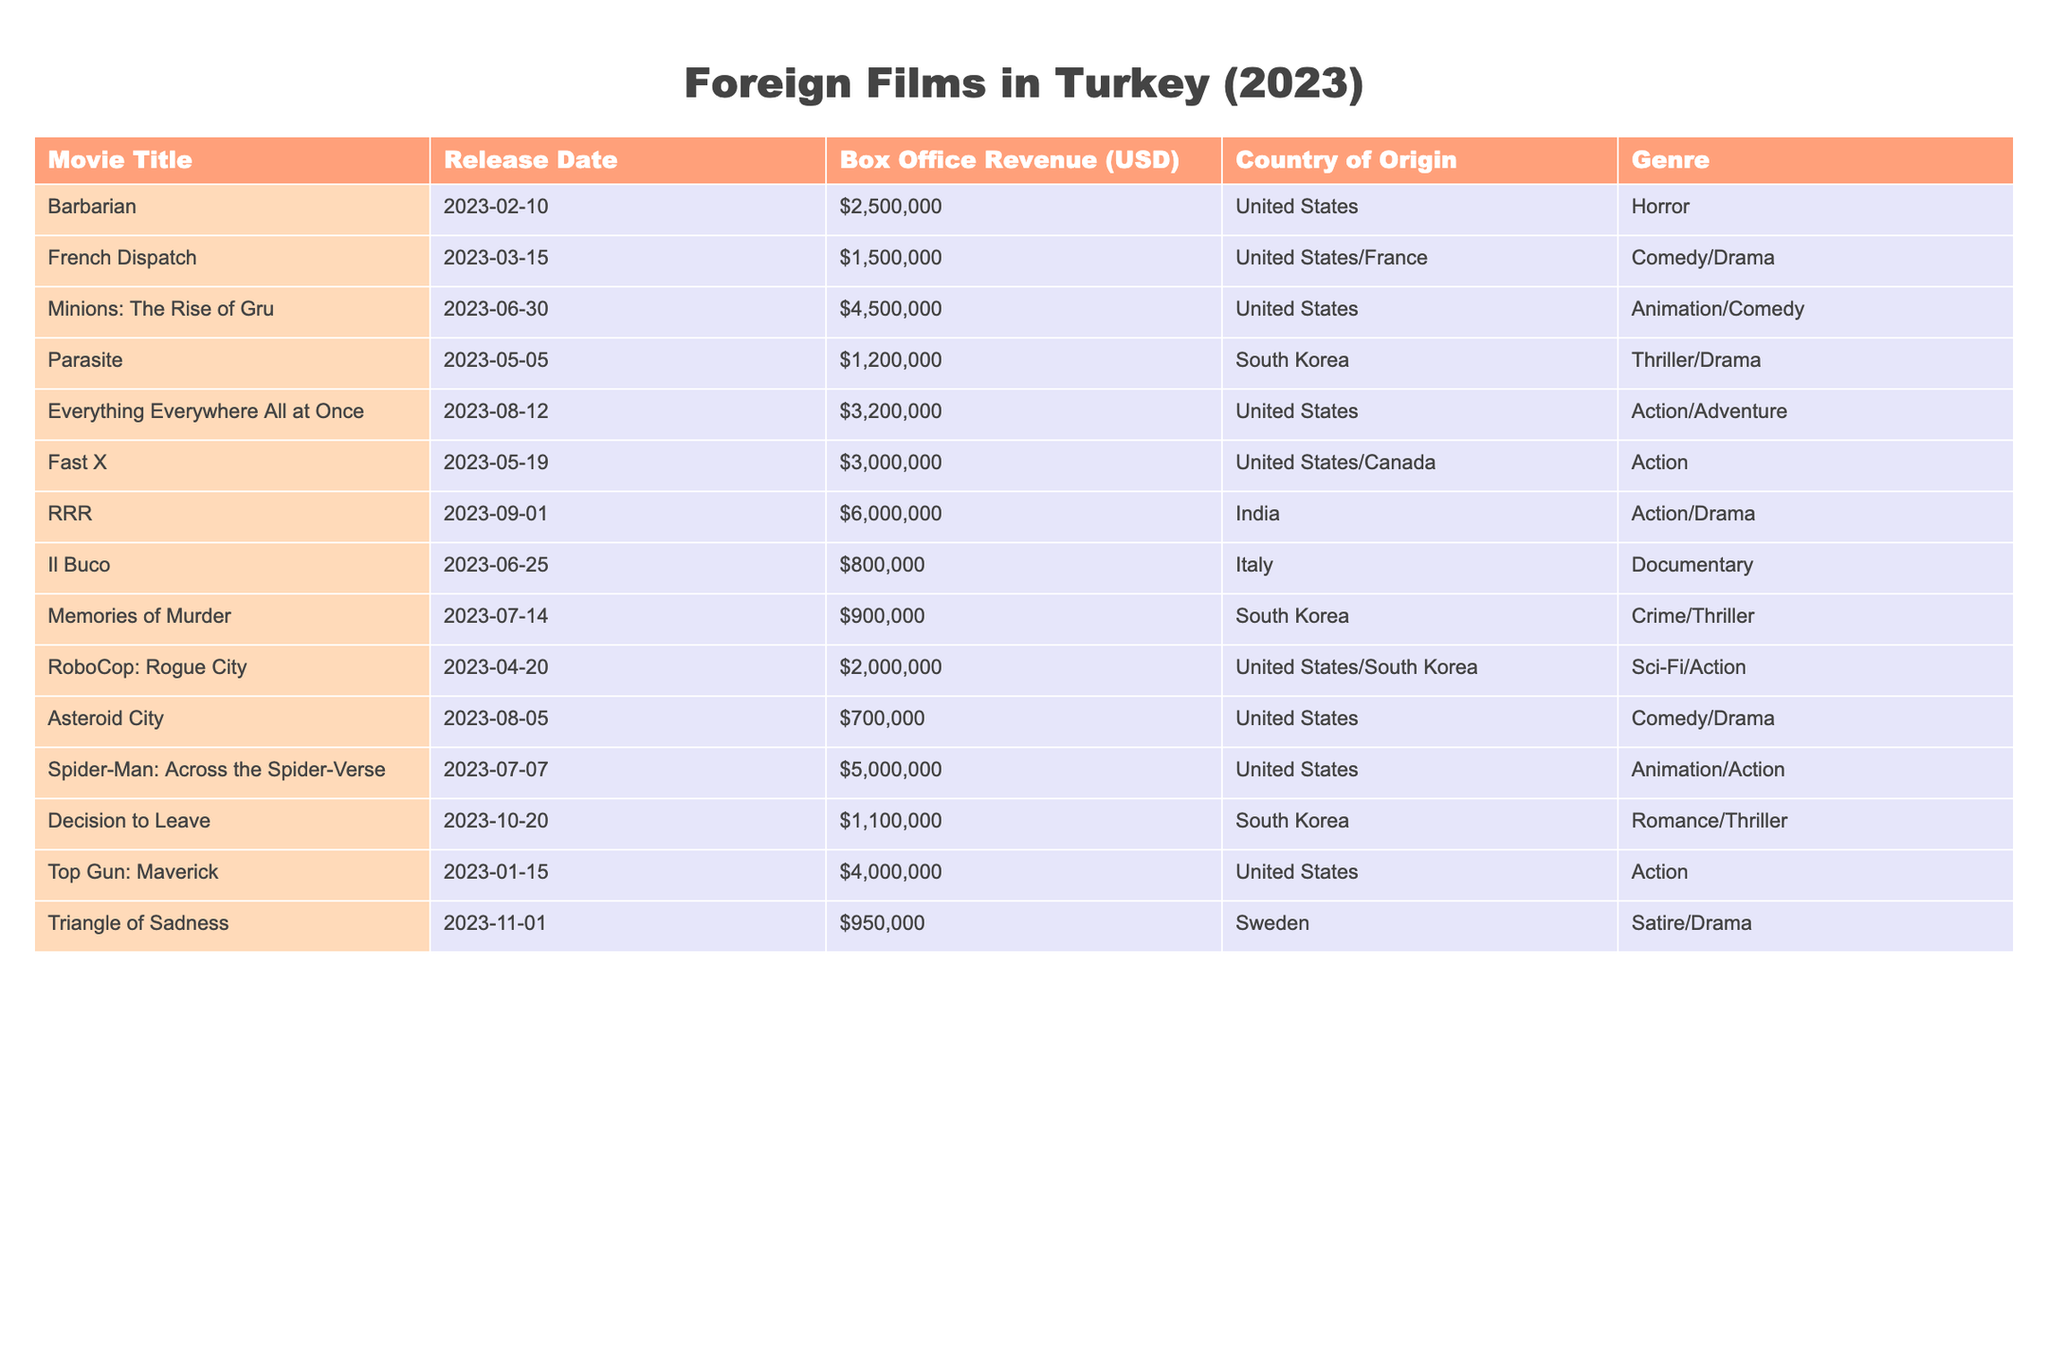What is the release date of "RRR"? The release date for "RRR" is provided in the table as 2023-09-01.
Answer: 2023-09-01 Which movie has the highest box office revenue? Looking through the box office revenue column, "RRR" shows a revenue of 6,000,000 USD, which is the highest among all listed films.
Answer: RRR How many movies were released in May 2023? The table shows three movies that were released in May: "Parasite" on May 5, "Fast X" on May 19, and "RoboCop: Rogue City" on April 20. However, only two fall in May.
Answer: 2 What is the total box office revenue from movies released in July 2023? Summing the box office revenue for movies released in July: "Memories of Murder" with 900,000 USD and "Spider-Man: Across the Spider-Verse" with 5,000,000 USD gives: 900,000 + 5,000,000 = 5,900,000 USD.
Answer: 5,900,000 USD Is "Asteroid City" more successful at the box office than "Everything Everywhere All at Once"? "Asteroid City" had a box office revenue of 700,000 USD, while "Everything Everywhere All at Once" grossed 3,200,000 USD. Since 700,000 is less than 3,200,000, "Asteroid City" is less successful.
Answer: No What is the average box office revenue of the movies from South Korea in this table? The South Korean films are "Parasite" (1,200,000 USD), "Memories of Murder" (900,000 USD), and "Decision to Leave" (1,100,000 USD). The sum is 1,200,000 + 900,000 + 1,100,000 = 3,200,000 USD. Since there are three movies, the average is 3,200,000 / 3 = 1,066,667 USD.
Answer: 1,066,667 USD How many genres are represented by the movies in the table? By examining the "Genre" column, the distinct genres in the list are Horror, Comedy/Drama, Animation/Comedy, Thriller/Drama, Action/Adventure, Action, Documentary, Crime/Thriller, Sci-Fi/Action, Romance/Thriller, Satire/Drama. This totals up to 11 unique genres.
Answer: 11 Which country produced the film "French Dispatch"? The "Country of Origin" column lists the "French Dispatch" as produced by both the United States and France.
Answer: United States/France 